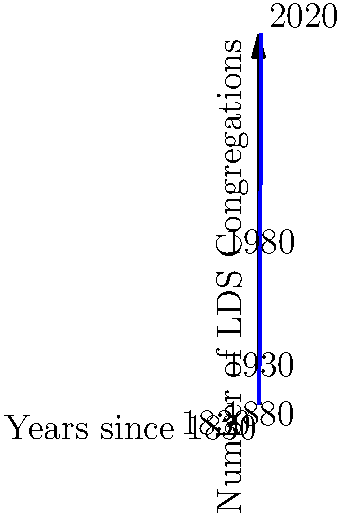The graph shows the growth of LDS congregations since the Church's founding in 1830. If we were to apply a coordinate transformation to stretch the y-axis by a factor of 2 while keeping the x-axis unchanged, what would be the new coordinates for the data point representing the year 1980? To solve this problem, let's follow these steps:

1. Identify the original coordinates for 1980:
   - x-coordinate: 150 (years since 1830)
   - y-coordinate: 15,000 (number of congregations)

2. Understand the transformation:
   - The x-axis remains unchanged
   - The y-axis is stretched by a factor of 2

3. Apply the transformation:
   - New x-coordinate: $x' = x = 150$ (unchanged)
   - New y-coordinate: $y' = 2y = 2 \times 15,000 = 30,000$

4. Express the new coordinates as an ordered pair:
   $(150, 30,000)$

This transformation effectively doubles the visual representation of the number of congregations while maintaining the same time scale, emphasizing the rapid growth of the Church in recent decades.
Answer: $(150, 30,000)$ 